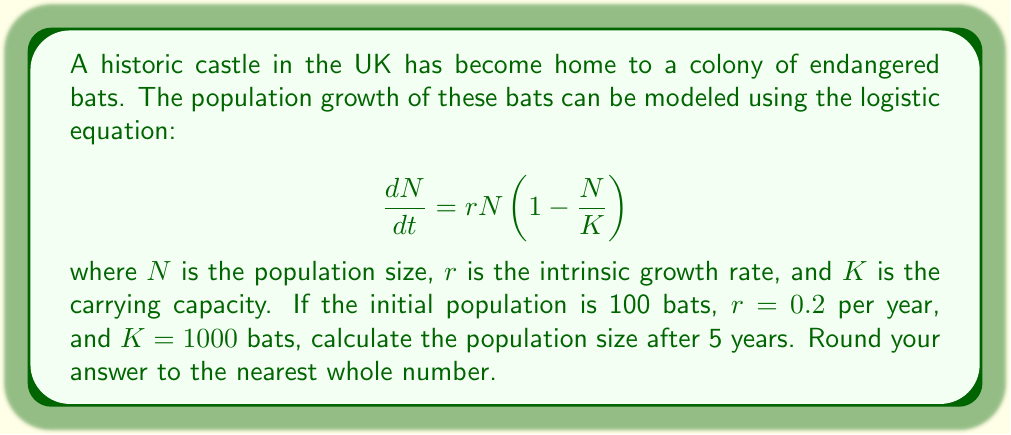Solve this math problem. To solve this problem, we need to use the analytical solution of the logistic equation:

$$N(t) = \frac{K}{1 + \left(\frac{K}{N_0} - 1\right)e^{-rt}}$$

Where:
$N(t)$ is the population size at time $t$
$K$ is the carrying capacity (1000 bats)
$N_0$ is the initial population size (100 bats)
$r$ is the intrinsic growth rate (0.2 per year)
$t$ is the time elapsed (5 years)

Let's substitute these values into the equation:

$$N(5) = \frac{1000}{1 + \left(\frac{1000}{100} - 1\right)e^{-0.2 \times 5}}$$

Simplifying:

$$N(5) = \frac{1000}{1 + (9)e^{-1}}$$

Using a calculator or computer to evaluate this expression:

$$N(5) \approx 259.6817$$

Rounding to the nearest whole number gives us 260 bats.
Answer: 260 bats 